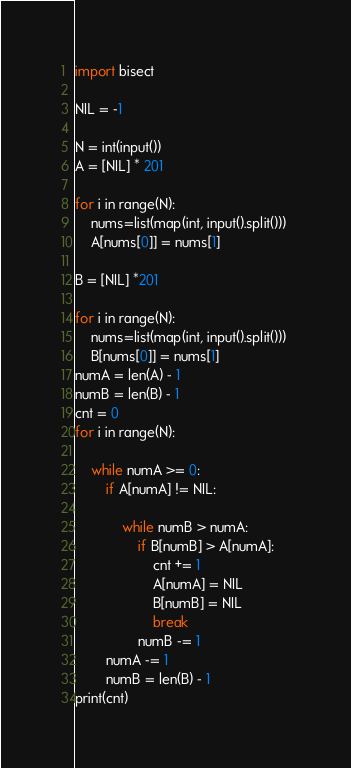<code> <loc_0><loc_0><loc_500><loc_500><_Python_>
import bisect

NIL = -1

N = int(input())
A = [NIL] * 201

for i in range(N):
    nums=list(map(int, input().split())) 
    A[nums[0]] = nums[1]

B = [NIL] *201

for i in range(N):
    nums=list(map(int, input().split())) 
    B[nums[0]] = nums[1]
numA = len(A) - 1
numB = len(B) - 1
cnt = 0
for i in range(N):
    
    while numA >= 0:
        if A[numA] != NIL:
            
            while numB > numA:
                if B[numB] > A[numA]:
                    cnt += 1
                    A[numA] = NIL
                    B[numB] = NIL
                    break
                numB -= 1
        numA -= 1
        numB = len(B) - 1
print(cnt)



</code> 